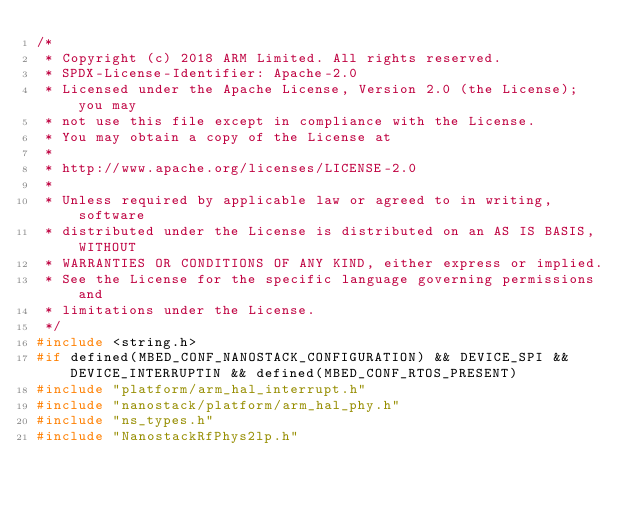<code> <loc_0><loc_0><loc_500><loc_500><_C++_>/*
 * Copyright (c) 2018 ARM Limited. All rights reserved.
 * SPDX-License-Identifier: Apache-2.0
 * Licensed under the Apache License, Version 2.0 (the License); you may
 * not use this file except in compliance with the License.
 * You may obtain a copy of the License at
 *
 * http://www.apache.org/licenses/LICENSE-2.0
 *
 * Unless required by applicable law or agreed to in writing, software
 * distributed under the License is distributed on an AS IS BASIS, WITHOUT
 * WARRANTIES OR CONDITIONS OF ANY KIND, either express or implied.
 * See the License for the specific language governing permissions and
 * limitations under the License.
 */
#include <string.h>
#if defined(MBED_CONF_NANOSTACK_CONFIGURATION) && DEVICE_SPI && DEVICE_INTERRUPTIN && defined(MBED_CONF_RTOS_PRESENT)
#include "platform/arm_hal_interrupt.h"
#include "nanostack/platform/arm_hal_phy.h"
#include "ns_types.h"
#include "NanostackRfPhys2lp.h"</code> 